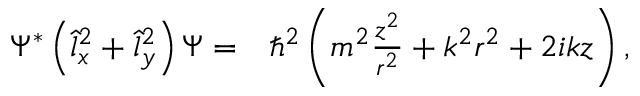<formula> <loc_0><loc_0><loc_500><loc_500>\begin{array} { r l } { \Psi ^ { * } \left ( \hat { l } _ { x } ^ { 2 } + \hat { l } _ { y } ^ { 2 } \right ) \Psi = } & \hbar { ^ } { 2 } \left ( m ^ { 2 } \frac { z ^ { 2 } } { r ^ { 2 } } + k ^ { 2 } r ^ { 2 } + 2 i k z \right ) , } \end{array}</formula> 